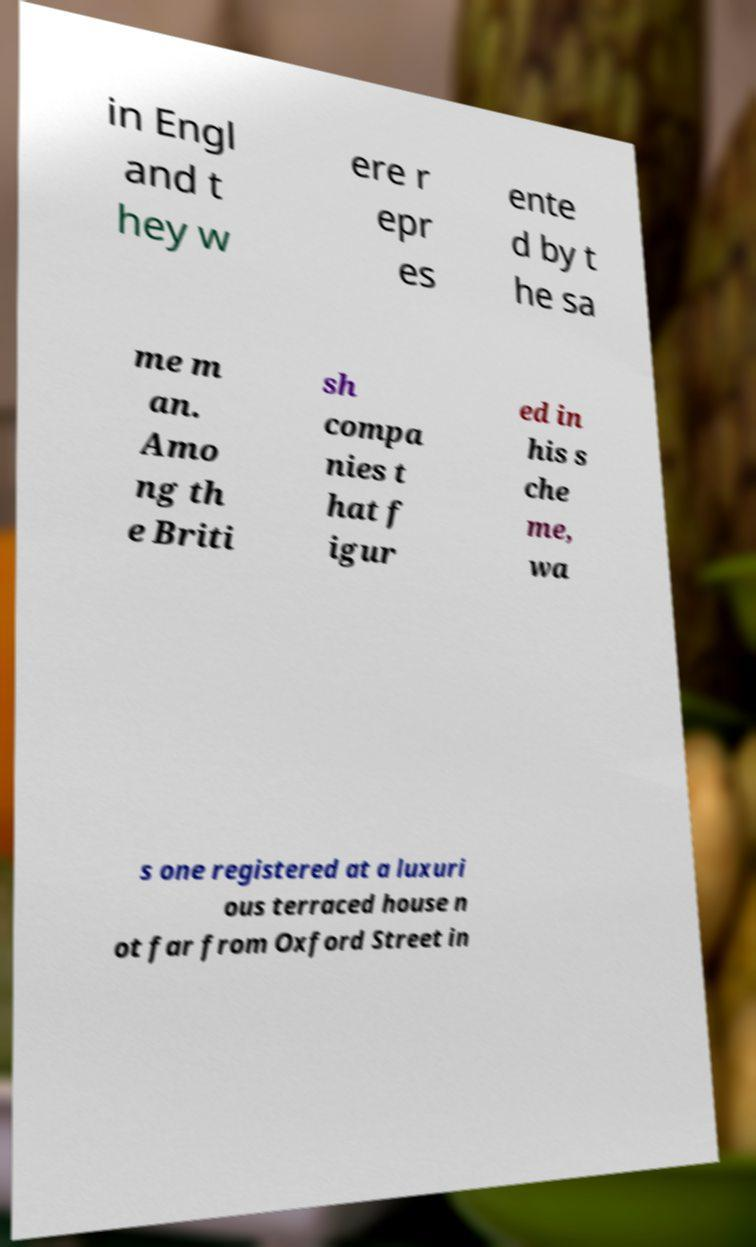What messages or text are displayed in this image? I need them in a readable, typed format. in Engl and t hey w ere r epr es ente d by t he sa me m an. Amo ng th e Briti sh compa nies t hat f igur ed in his s che me, wa s one registered at a luxuri ous terraced house n ot far from Oxford Street in 